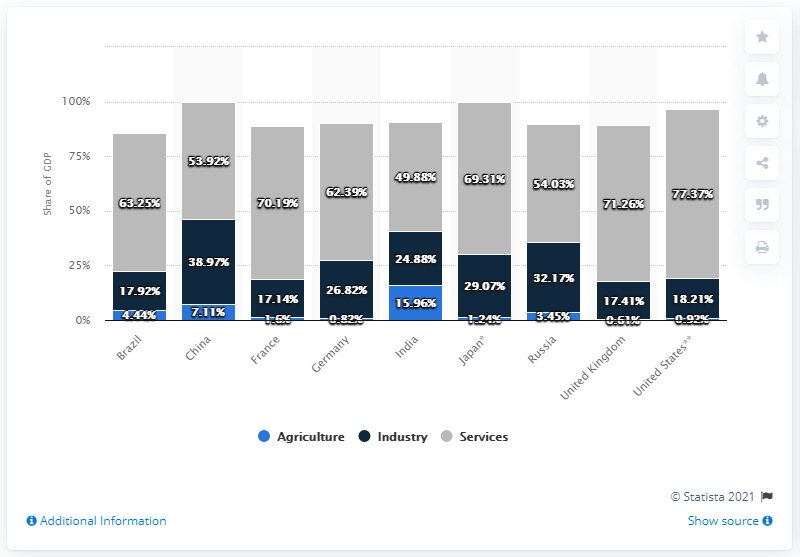Identify some key points in this picture. In 2019, the agricultural sector in France accounted for approximately 1.6% of the country's GDP. 